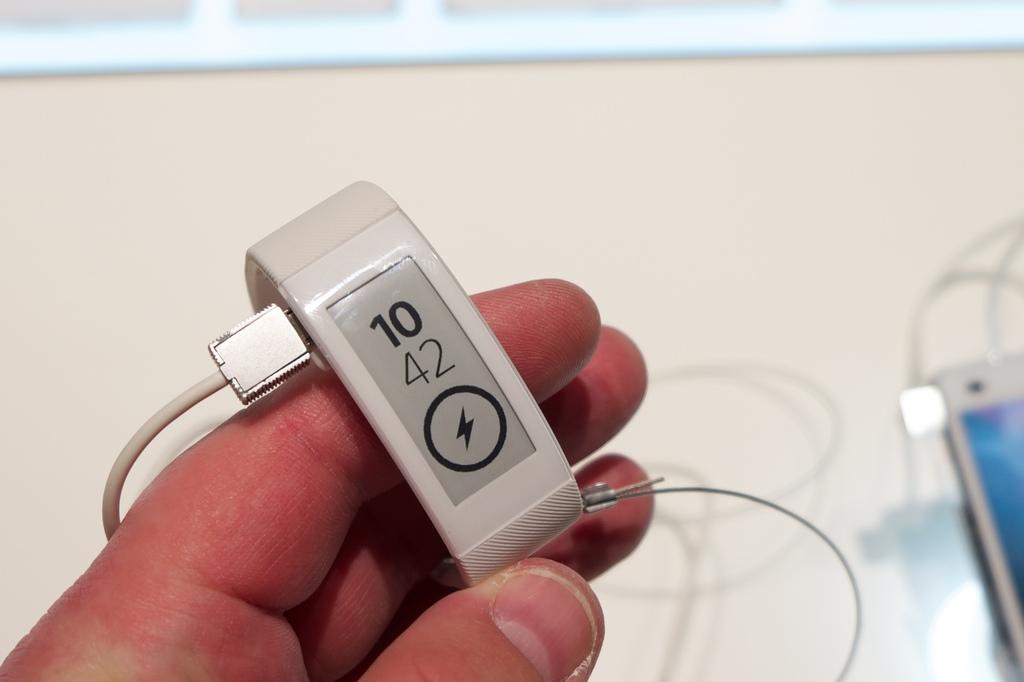What time is shown on this watch?
Ensure brevity in your answer.  10:42. 